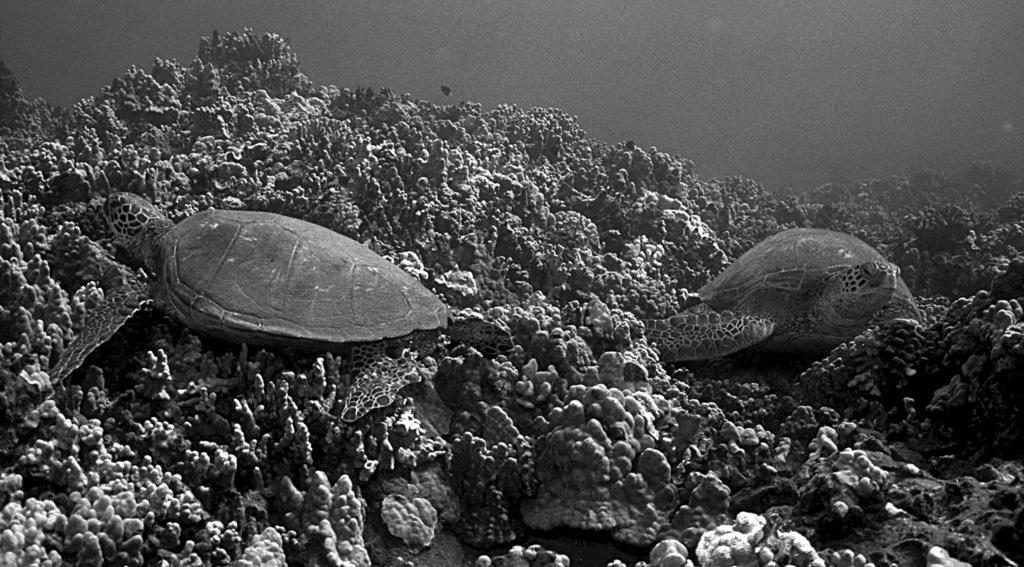Can you describe this image briefly? This is a black and white image. In this image we can see turtles and we can see the coral reefs. 